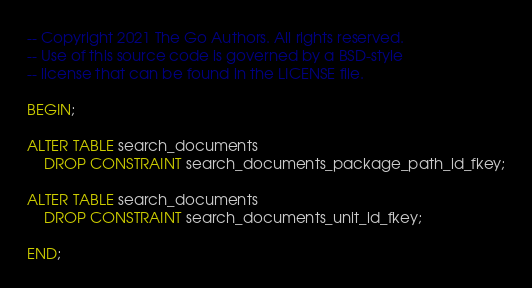Convert code to text. <code><loc_0><loc_0><loc_500><loc_500><_SQL_>-- Copyright 2021 The Go Authors. All rights reserved.
-- Use of this source code is governed by a BSD-style
-- license that can be found in the LICENSE file.

BEGIN;

ALTER TABLE search_documents
    DROP CONSTRAINT search_documents_package_path_id_fkey;

ALTER TABLE search_documents
    DROP CONSTRAINT search_documents_unit_id_fkey;

END;
</code> 